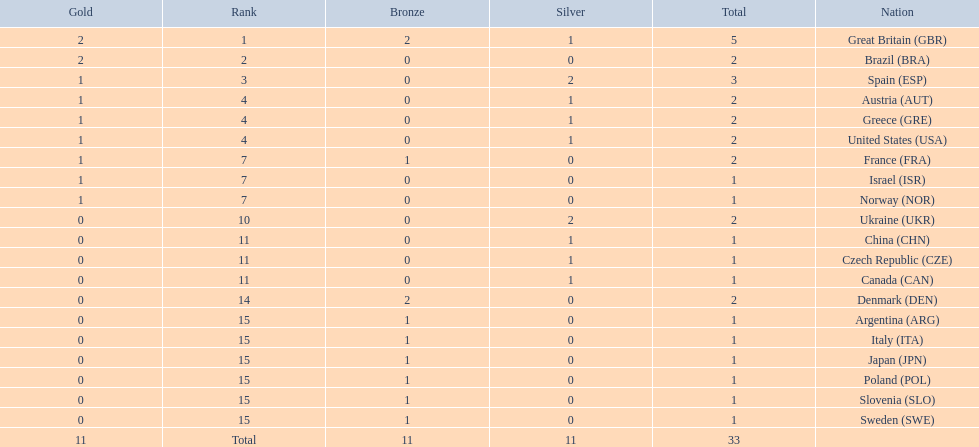Who won more gold medals than spain? Great Britain (GBR), Brazil (BRA). 